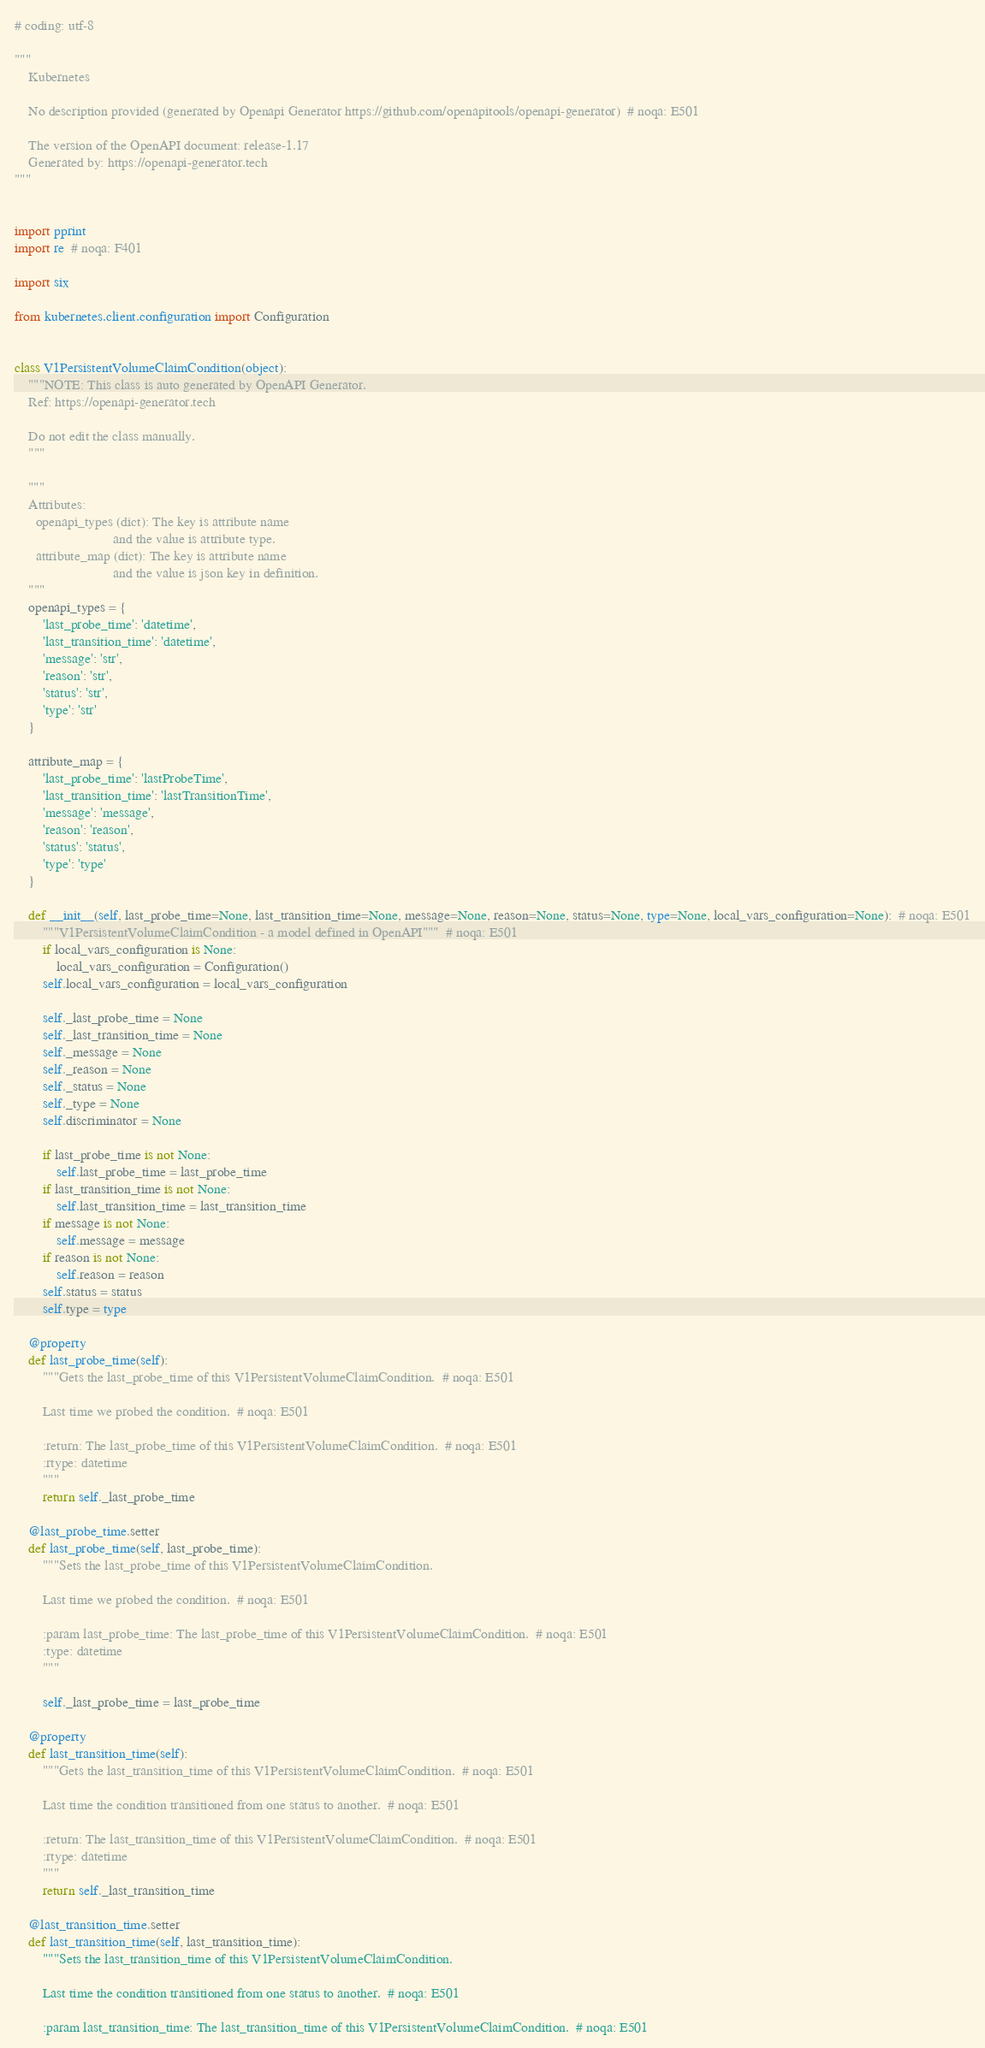<code> <loc_0><loc_0><loc_500><loc_500><_Python_># coding: utf-8

"""
    Kubernetes

    No description provided (generated by Openapi Generator https://github.com/openapitools/openapi-generator)  # noqa: E501

    The version of the OpenAPI document: release-1.17
    Generated by: https://openapi-generator.tech
"""


import pprint
import re  # noqa: F401

import six

from kubernetes.client.configuration import Configuration


class V1PersistentVolumeClaimCondition(object):
    """NOTE: This class is auto generated by OpenAPI Generator.
    Ref: https://openapi-generator.tech

    Do not edit the class manually.
    """

    """
    Attributes:
      openapi_types (dict): The key is attribute name
                            and the value is attribute type.
      attribute_map (dict): The key is attribute name
                            and the value is json key in definition.
    """
    openapi_types = {
        'last_probe_time': 'datetime',
        'last_transition_time': 'datetime',
        'message': 'str',
        'reason': 'str',
        'status': 'str',
        'type': 'str'
    }

    attribute_map = {
        'last_probe_time': 'lastProbeTime',
        'last_transition_time': 'lastTransitionTime',
        'message': 'message',
        'reason': 'reason',
        'status': 'status',
        'type': 'type'
    }

    def __init__(self, last_probe_time=None, last_transition_time=None, message=None, reason=None, status=None, type=None, local_vars_configuration=None):  # noqa: E501
        """V1PersistentVolumeClaimCondition - a model defined in OpenAPI"""  # noqa: E501
        if local_vars_configuration is None:
            local_vars_configuration = Configuration()
        self.local_vars_configuration = local_vars_configuration

        self._last_probe_time = None
        self._last_transition_time = None
        self._message = None
        self._reason = None
        self._status = None
        self._type = None
        self.discriminator = None

        if last_probe_time is not None:
            self.last_probe_time = last_probe_time
        if last_transition_time is not None:
            self.last_transition_time = last_transition_time
        if message is not None:
            self.message = message
        if reason is not None:
            self.reason = reason
        self.status = status
        self.type = type

    @property
    def last_probe_time(self):
        """Gets the last_probe_time of this V1PersistentVolumeClaimCondition.  # noqa: E501

        Last time we probed the condition.  # noqa: E501

        :return: The last_probe_time of this V1PersistentVolumeClaimCondition.  # noqa: E501
        :rtype: datetime
        """
        return self._last_probe_time

    @last_probe_time.setter
    def last_probe_time(self, last_probe_time):
        """Sets the last_probe_time of this V1PersistentVolumeClaimCondition.

        Last time we probed the condition.  # noqa: E501

        :param last_probe_time: The last_probe_time of this V1PersistentVolumeClaimCondition.  # noqa: E501
        :type: datetime
        """

        self._last_probe_time = last_probe_time

    @property
    def last_transition_time(self):
        """Gets the last_transition_time of this V1PersistentVolumeClaimCondition.  # noqa: E501

        Last time the condition transitioned from one status to another.  # noqa: E501

        :return: The last_transition_time of this V1PersistentVolumeClaimCondition.  # noqa: E501
        :rtype: datetime
        """
        return self._last_transition_time

    @last_transition_time.setter
    def last_transition_time(self, last_transition_time):
        """Sets the last_transition_time of this V1PersistentVolumeClaimCondition.

        Last time the condition transitioned from one status to another.  # noqa: E501

        :param last_transition_time: The last_transition_time of this V1PersistentVolumeClaimCondition.  # noqa: E501</code> 